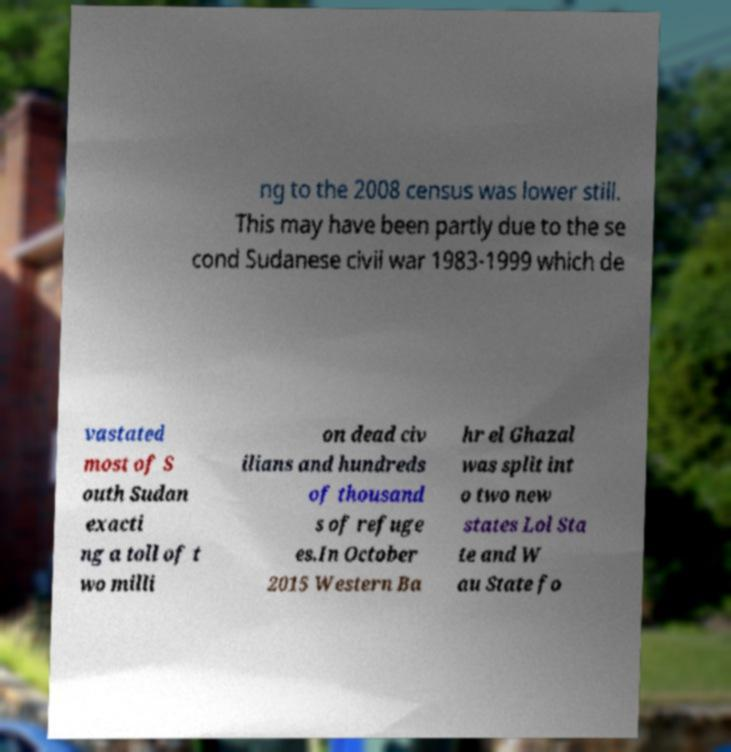Could you extract and type out the text from this image? ng to the 2008 census was lower still. This may have been partly due to the se cond Sudanese civil war 1983-1999 which de vastated most of S outh Sudan exacti ng a toll of t wo milli on dead civ ilians and hundreds of thousand s of refuge es.In October 2015 Western Ba hr el Ghazal was split int o two new states Lol Sta te and W au State fo 